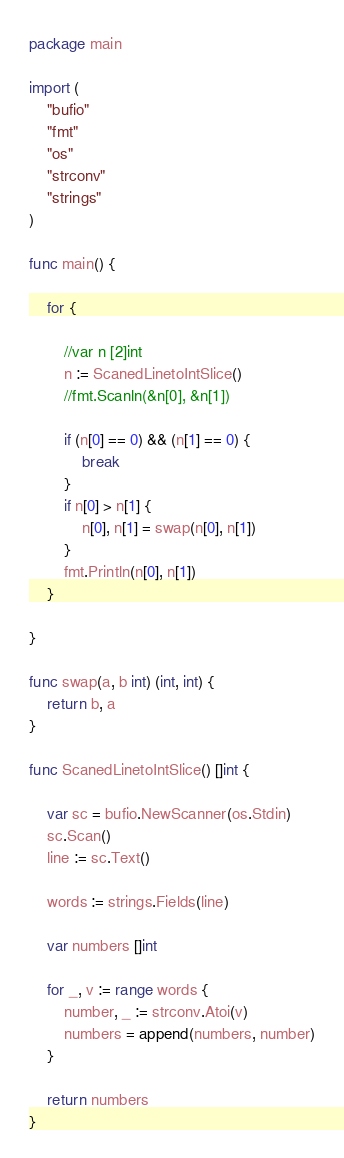Convert code to text. <code><loc_0><loc_0><loc_500><loc_500><_Go_>package main

import (
	"bufio"
	"fmt"
	"os"
	"strconv"
	"strings"
)

func main() {

	for {

		//var n [2]int
		n := ScanedLinetoIntSlice()
		//fmt.Scanln(&n[0], &n[1])

		if (n[0] == 0) && (n[1] == 0) {
			break
		}
		if n[0] > n[1] {
			n[0], n[1] = swap(n[0], n[1])
		}
		fmt.Println(n[0], n[1])
	}

}

func swap(a, b int) (int, int) {
	return b, a
}

func ScanedLinetoIntSlice() []int {

	var sc = bufio.NewScanner(os.Stdin)
	sc.Scan()
	line := sc.Text()

	words := strings.Fields(line)

	var numbers []int

	for _, v := range words {
		number, _ := strconv.Atoi(v)
		numbers = append(numbers, number)
	}

	return numbers
}

</code> 